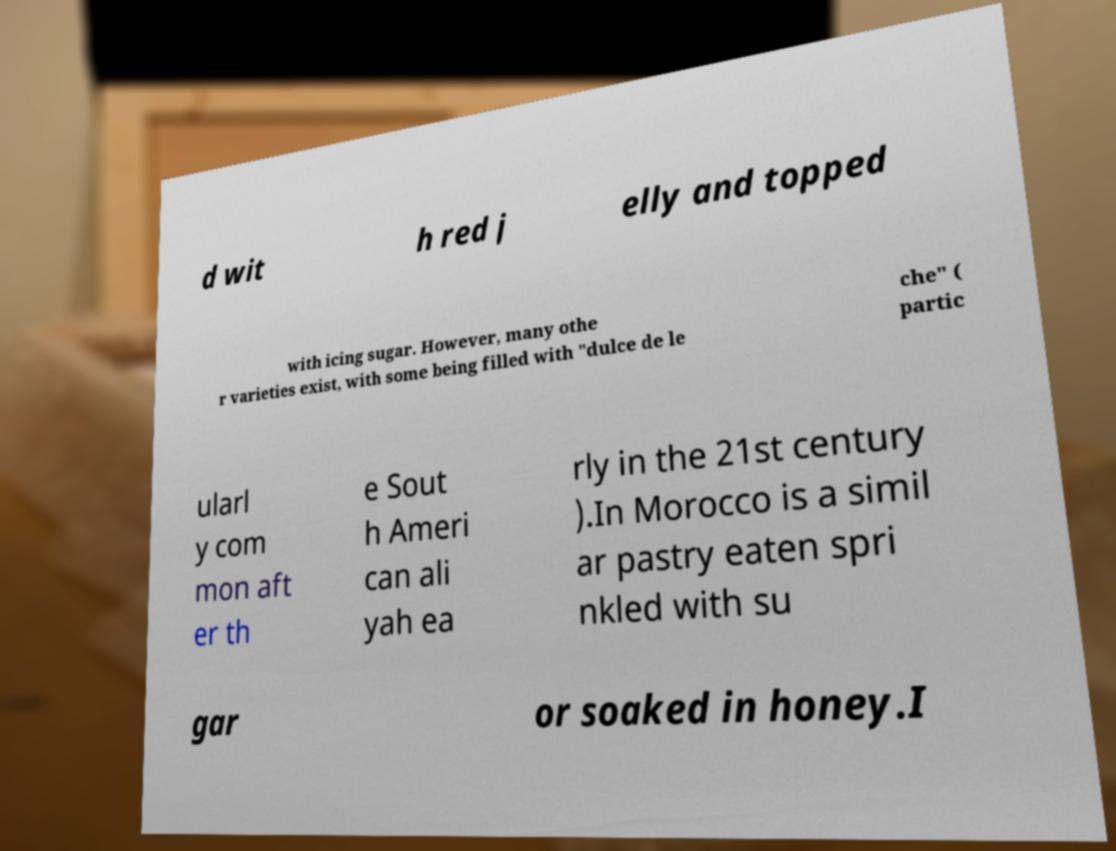I need the written content from this picture converted into text. Can you do that? d wit h red j elly and topped with icing sugar. However, many othe r varieties exist, with some being filled with "dulce de le che" ( partic ularl y com mon aft er th e Sout h Ameri can ali yah ea rly in the 21st century ).In Morocco is a simil ar pastry eaten spri nkled with su gar or soaked in honey.I 